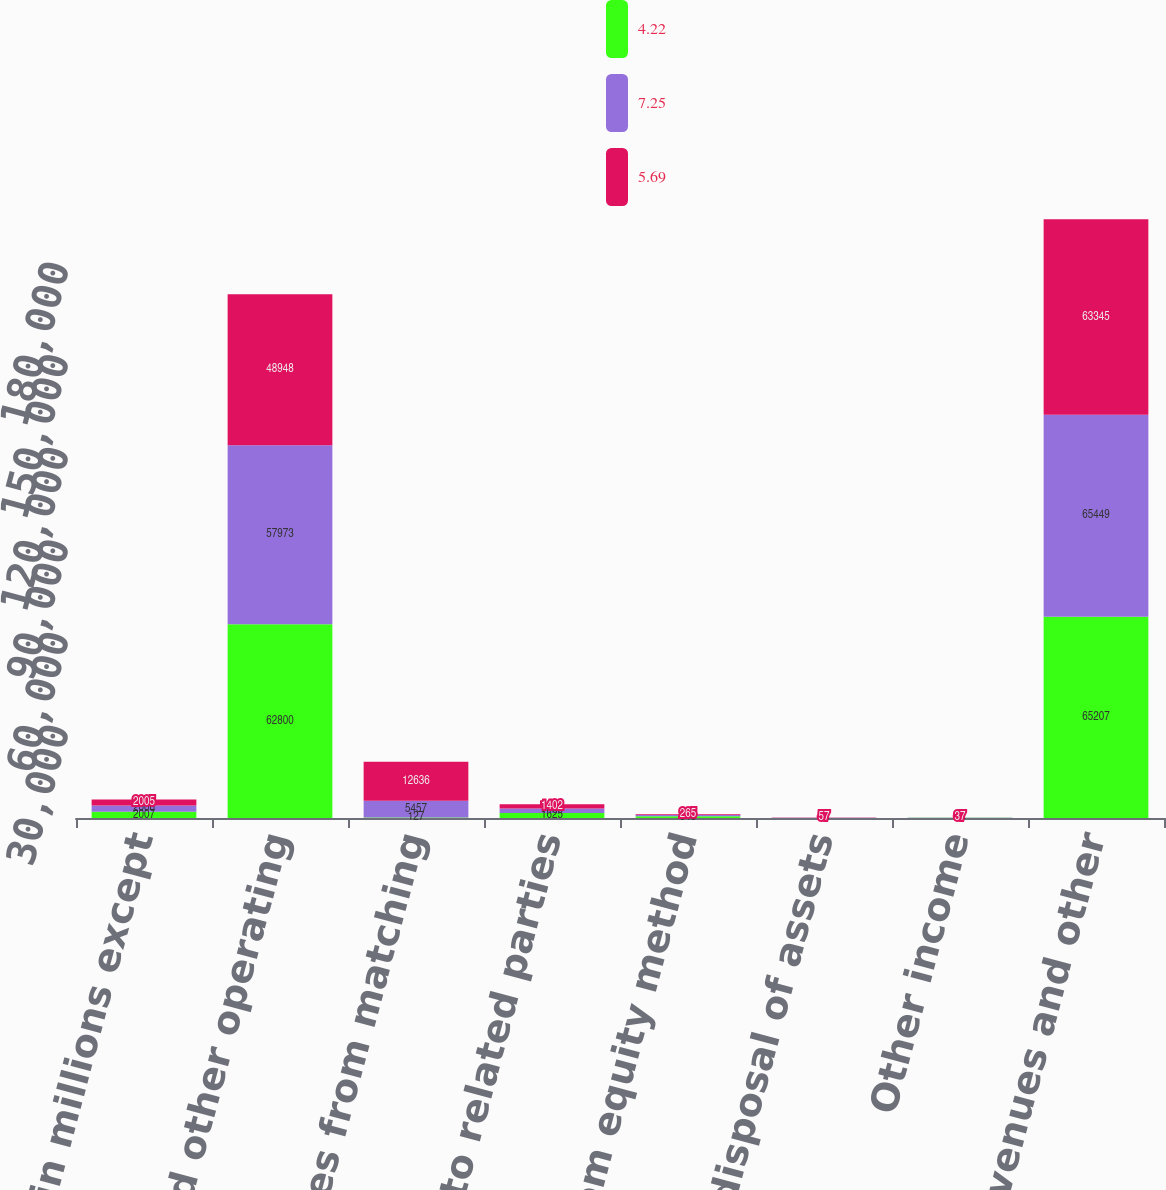<chart> <loc_0><loc_0><loc_500><loc_500><stacked_bar_chart><ecel><fcel>(Dollars in millions except<fcel>Sales and other operating<fcel>Revenues from matching<fcel>Sales to related parties<fcel>Income from equity method<fcel>Net gain on disposal of assets<fcel>Other income<fcel>Total revenues and other<nl><fcel>4.22<fcel>2007<fcel>62800<fcel>127<fcel>1625<fcel>545<fcel>36<fcel>74<fcel>65207<nl><fcel>7.25<fcel>2006<fcel>57973<fcel>5457<fcel>1466<fcel>391<fcel>77<fcel>85<fcel>65449<nl><fcel>5.69<fcel>2005<fcel>48948<fcel>12636<fcel>1402<fcel>265<fcel>57<fcel>37<fcel>63345<nl></chart> 